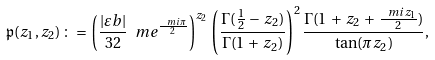<formula> <loc_0><loc_0><loc_500><loc_500>\mathfrak { p } ( z _ { 1 } , z _ { 2 } ) \, \colon = \, \left ( \frac { | \varepsilon b | } { 3 2 } \ m e ^ { \frac { \ m i \pi } { 2 } } \right ) ^ { z _ { 2 } } \, \left ( \frac { \Gamma ( \frac { 1 } { 2 } \, - \, z _ { 2 } ) } { \Gamma ( 1 \, + \, z _ { 2 } ) } \right ) ^ { 2 } \frac { \Gamma ( 1 \, + \, z _ { 2 } \, + \, \frac { \ m i z _ { 1 } } { 2 } ) } { \tan ( \pi z _ { 2 } ) } ,</formula> 